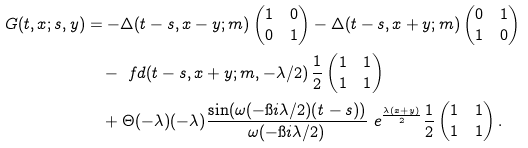Convert formula to latex. <formula><loc_0><loc_0><loc_500><loc_500>G ( t , x ; s , y ) & = - \Delta ( t - s , x - y ; m ) \begin{pmatrix} 1 & 0 \\ 0 & 1 \end{pmatrix} - \Delta ( t - s , x + y ; m ) \begin{pmatrix} 0 & 1 \\ 1 & 0 \end{pmatrix} \\ & \quad - \ f d ( t - s , x + y ; m , - \lambda / 2 ) \, \frac { 1 } { 2 } \begin{pmatrix} 1 & 1 \\ 1 & 1 \end{pmatrix} \\ & \quad + \Theta ( - \lambda ) ( - \lambda ) \frac { \sin ( \omega ( - \i i \lambda / 2 ) ( t - s ) ) } { \omega ( - \i i \lambda / 2 ) } \ e ^ { \frac { \lambda ( x + y ) } { 2 } } \frac { 1 } { 2 } \begin{pmatrix} 1 & 1 \\ 1 & 1 \end{pmatrix} .</formula> 